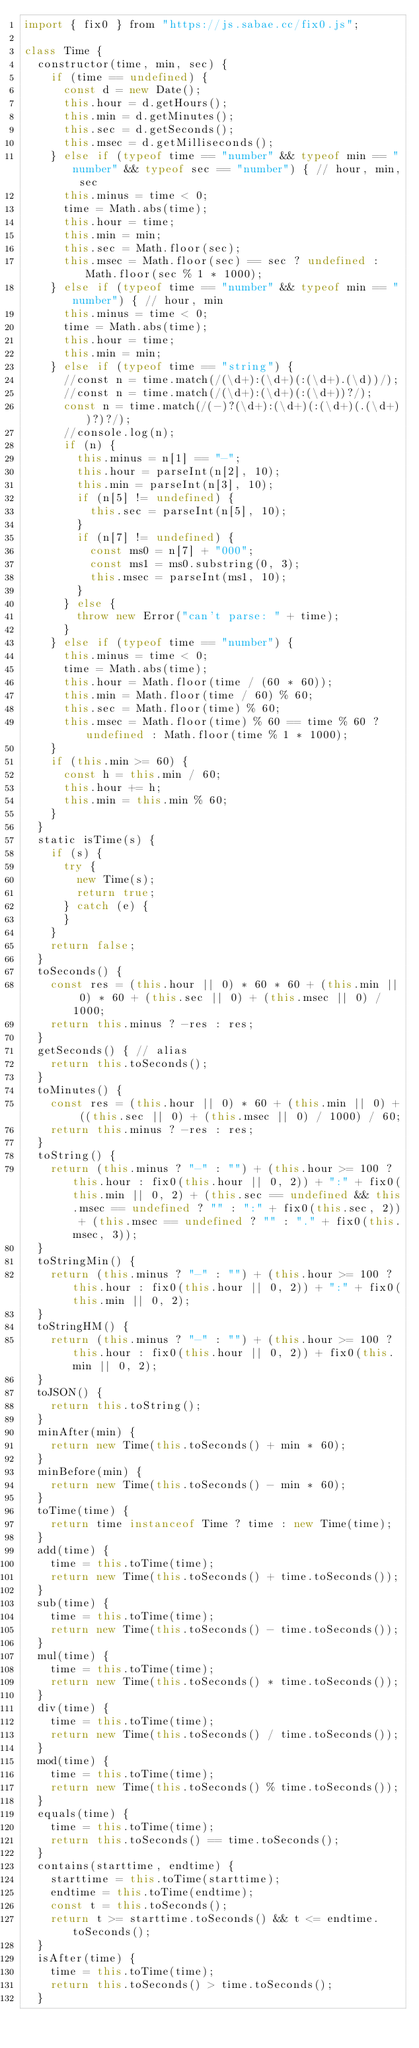<code> <loc_0><loc_0><loc_500><loc_500><_JavaScript_>import { fix0 } from "https://js.sabae.cc/fix0.js";

class Time {
  constructor(time, min, sec) {
    if (time == undefined) {
      const d = new Date();
      this.hour = d.getHours();
      this.min = d.getMinutes();
      this.sec = d.getSeconds();
      this.msec = d.getMilliseconds();
    } else if (typeof time == "number" && typeof min == "number" && typeof sec == "number") { // hour, min, sec
      this.minus = time < 0;
      time = Math.abs(time);
      this.hour = time;
      this.min = min;
      this.sec = Math.floor(sec);
      this.msec = Math.floor(sec) == sec ? undefined : Math.floor(sec % 1 * 1000);
    } else if (typeof time == "number" && typeof min == "number") { // hour, min
      this.minus = time < 0;
      time = Math.abs(time);
      this.hour = time;
      this.min = min;
    } else if (typeof time == "string") {
      //const n = time.match(/(\d+):(\d+)(:(\d+).(\d))/);
      //const n = time.match(/(\d+):(\d+)(:(\d+))?/);
      const n = time.match(/(-)?(\d+):(\d+)(:(\d+)(.(\d+))?)?/);
      //console.log(n);
      if (n) {
        this.minus = n[1] == "-";
        this.hour = parseInt(n[2], 10);
        this.min = parseInt(n[3], 10);
        if (n[5] != undefined) {
          this.sec = parseInt(n[5], 10);
        }
        if (n[7] != undefined) {
          const ms0 = n[7] + "000";
          const ms1 = ms0.substring(0, 3);
          this.msec = parseInt(ms1, 10);
        }
      } else {
        throw new Error("can't parse: " + time);
      }
    } else if (typeof time == "number") {
      this.minus = time < 0;
      time = Math.abs(time);
      this.hour = Math.floor(time / (60 * 60));
      this.min = Math.floor(time / 60) % 60;
      this.sec = Math.floor(time) % 60;
      this.msec = Math.floor(time) % 60 == time % 60 ? undefined : Math.floor(time % 1 * 1000);
    }
    if (this.min >= 60) {
      const h = this.min / 60;
      this.hour += h;
      this.min = this.min % 60;
    }
  }
  static isTime(s) {
    if (s) {
      try {
        new Time(s);
        return true;
      } catch (e) {
      }
    }
    return false;
  }
  toSeconds() {
    const res = (this.hour || 0) * 60 * 60 + (this.min || 0) * 60 + (this.sec || 0) + (this.msec || 0) / 1000;
    return this.minus ? -res : res;
  }
  getSeconds() { // alias
    return this.toSeconds();
  }
  toMinutes() {
    const res = (this.hour || 0) * 60 + (this.min || 0) + ((this.sec || 0) + (this.msec || 0) / 1000) / 60;
    return this.minus ? -res : res;
  }
  toString() {
    return (this.minus ? "-" : "") + (this.hour >= 100 ? this.hour : fix0(this.hour || 0, 2)) + ":" + fix0(this.min || 0, 2) + (this.sec == undefined && this.msec == undefined ? "" : ":" + fix0(this.sec, 2)) + (this.msec == undefined ? "" : "." + fix0(this.msec, 3));
  }
  toStringMin() {
    return (this.minus ? "-" : "") + (this.hour >= 100 ? this.hour : fix0(this.hour || 0, 2)) + ":" + fix0(this.min || 0, 2);
  }
  toStringHM() {
    return (this.minus ? "-" : "") + (this.hour >= 100 ? this.hour : fix0(this.hour || 0, 2)) + fix0(this.min || 0, 2);
  }
  toJSON() {
    return this.toString();
  }
  minAfter(min) {
    return new Time(this.toSeconds() + min * 60);
  }
  minBefore(min) {
    return new Time(this.toSeconds() - min * 60);
  }
  toTime(time) {
    return time instanceof Time ? time : new Time(time);
  }
  add(time) {
    time = this.toTime(time);
    return new Time(this.toSeconds() + time.toSeconds());
  }
  sub(time) {
    time = this.toTime(time);
    return new Time(this.toSeconds() - time.toSeconds());
  }
  mul(time) {
    time = this.toTime(time);
    return new Time(this.toSeconds() * time.toSeconds());
  }
  div(time) {
    time = this.toTime(time);
    return new Time(this.toSeconds() / time.toSeconds());
  }
  mod(time) {
    time = this.toTime(time);
    return new Time(this.toSeconds() % time.toSeconds());
  }
  equals(time) {
    time = this.toTime(time);
    return this.toSeconds() == time.toSeconds();
  }
  contains(starttime, endtime) {
    starttime = this.toTime(starttime);
    endtime = this.toTime(endtime);
    const t = this.toSeconds();
    return t >= starttime.toSeconds() && t <= endtime.toSeconds();
  }
  isAfter(time) {
    time = this.toTime(time);
    return this.toSeconds() > time.toSeconds();
  }</code> 